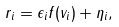<formula> <loc_0><loc_0><loc_500><loc_500>r _ { i } = \epsilon _ { i } f ( v _ { i } ) + \eta _ { i } ,</formula> 